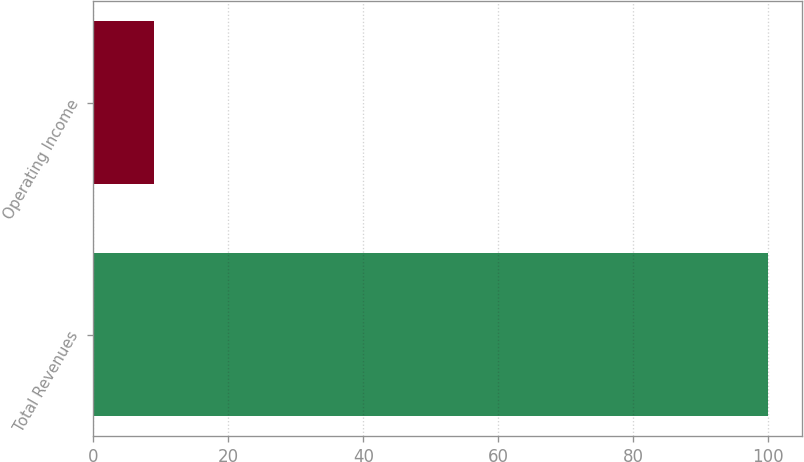Convert chart. <chart><loc_0><loc_0><loc_500><loc_500><bar_chart><fcel>Total Revenues<fcel>Operating Income<nl><fcel>100<fcel>9<nl></chart> 